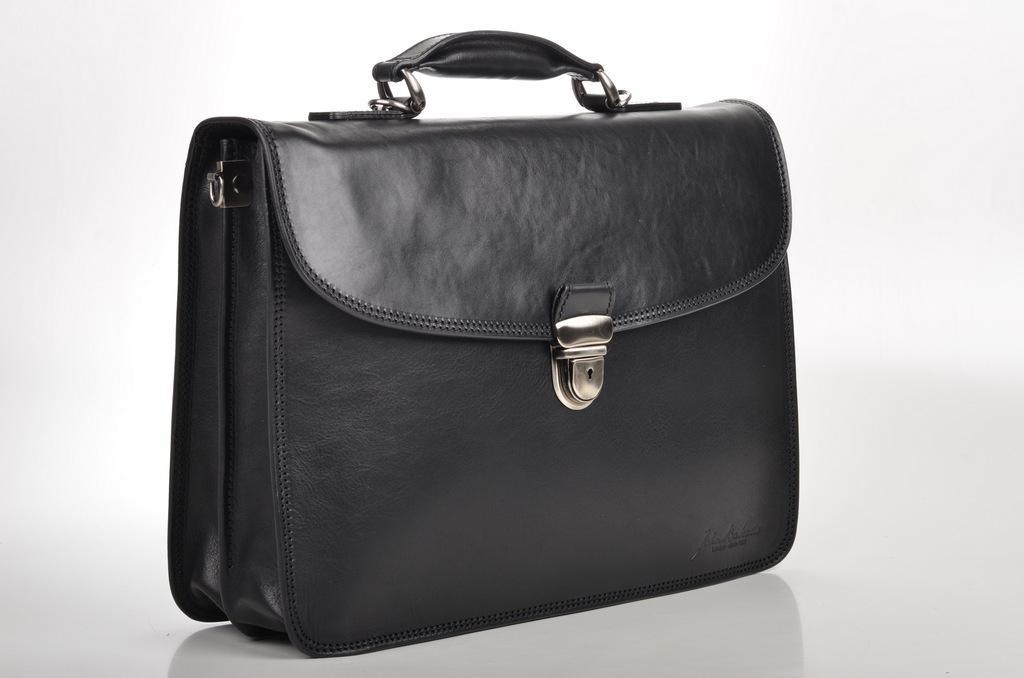In one or two sentences, can you explain what this image depicts? This is a bag. 